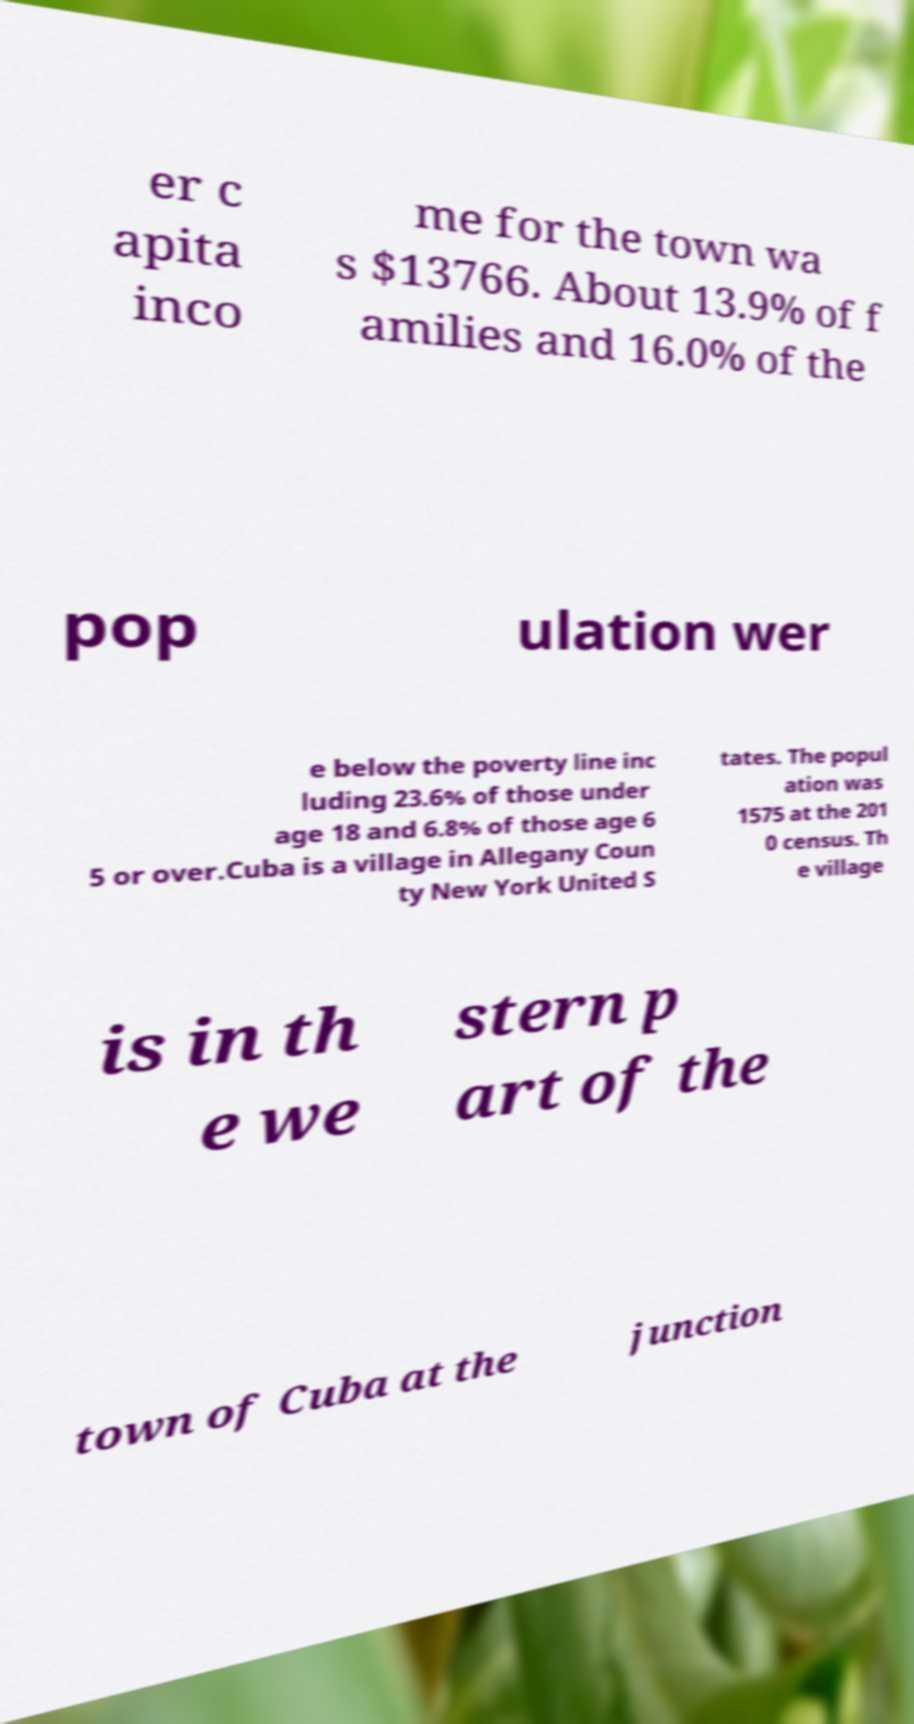I need the written content from this picture converted into text. Can you do that? er c apita inco me for the town wa s $13766. About 13.9% of f amilies and 16.0% of the pop ulation wer e below the poverty line inc luding 23.6% of those under age 18 and 6.8% of those age 6 5 or over.Cuba is a village in Allegany Coun ty New York United S tates. The popul ation was 1575 at the 201 0 census. Th e village is in th e we stern p art of the town of Cuba at the junction 